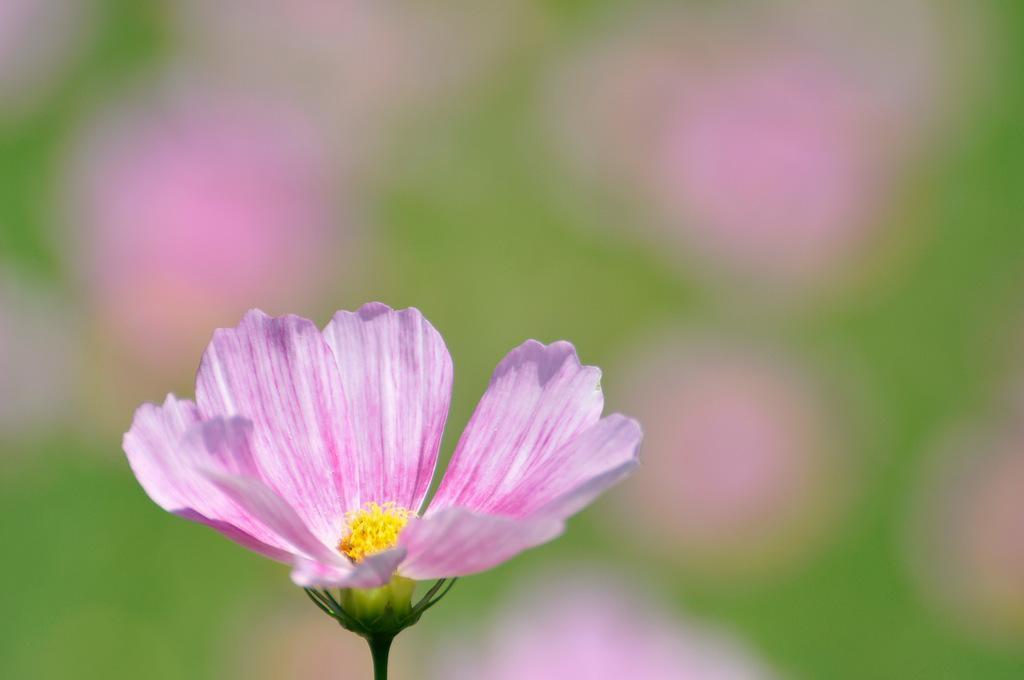In one or two sentences, can you explain what this image depicts? In this image I can see a flower. I can also see the background is blurred. 